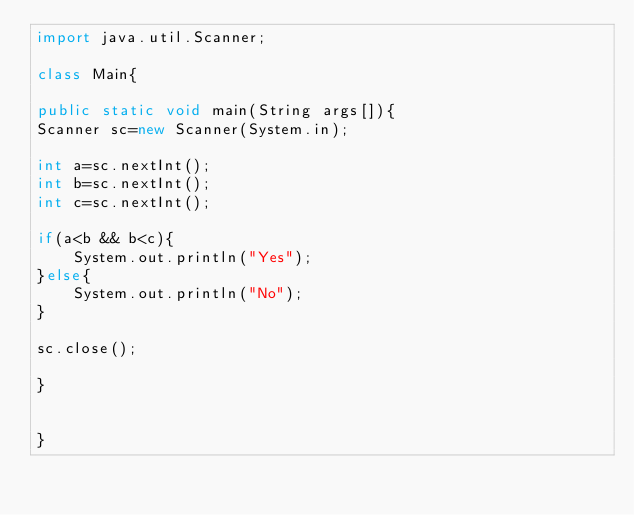Convert code to text. <code><loc_0><loc_0><loc_500><loc_500><_Java_>import java.util.Scanner;

class Main{

public static void main(String args[]){
Scanner sc=new Scanner(System.in);

int a=sc.nextInt();
int b=sc.nextInt();
int c=sc.nextInt();

if(a<b && b<c){
    System.out.println("Yes");
}else{
    System.out.println("No");
}

sc.close();

}


}
</code> 